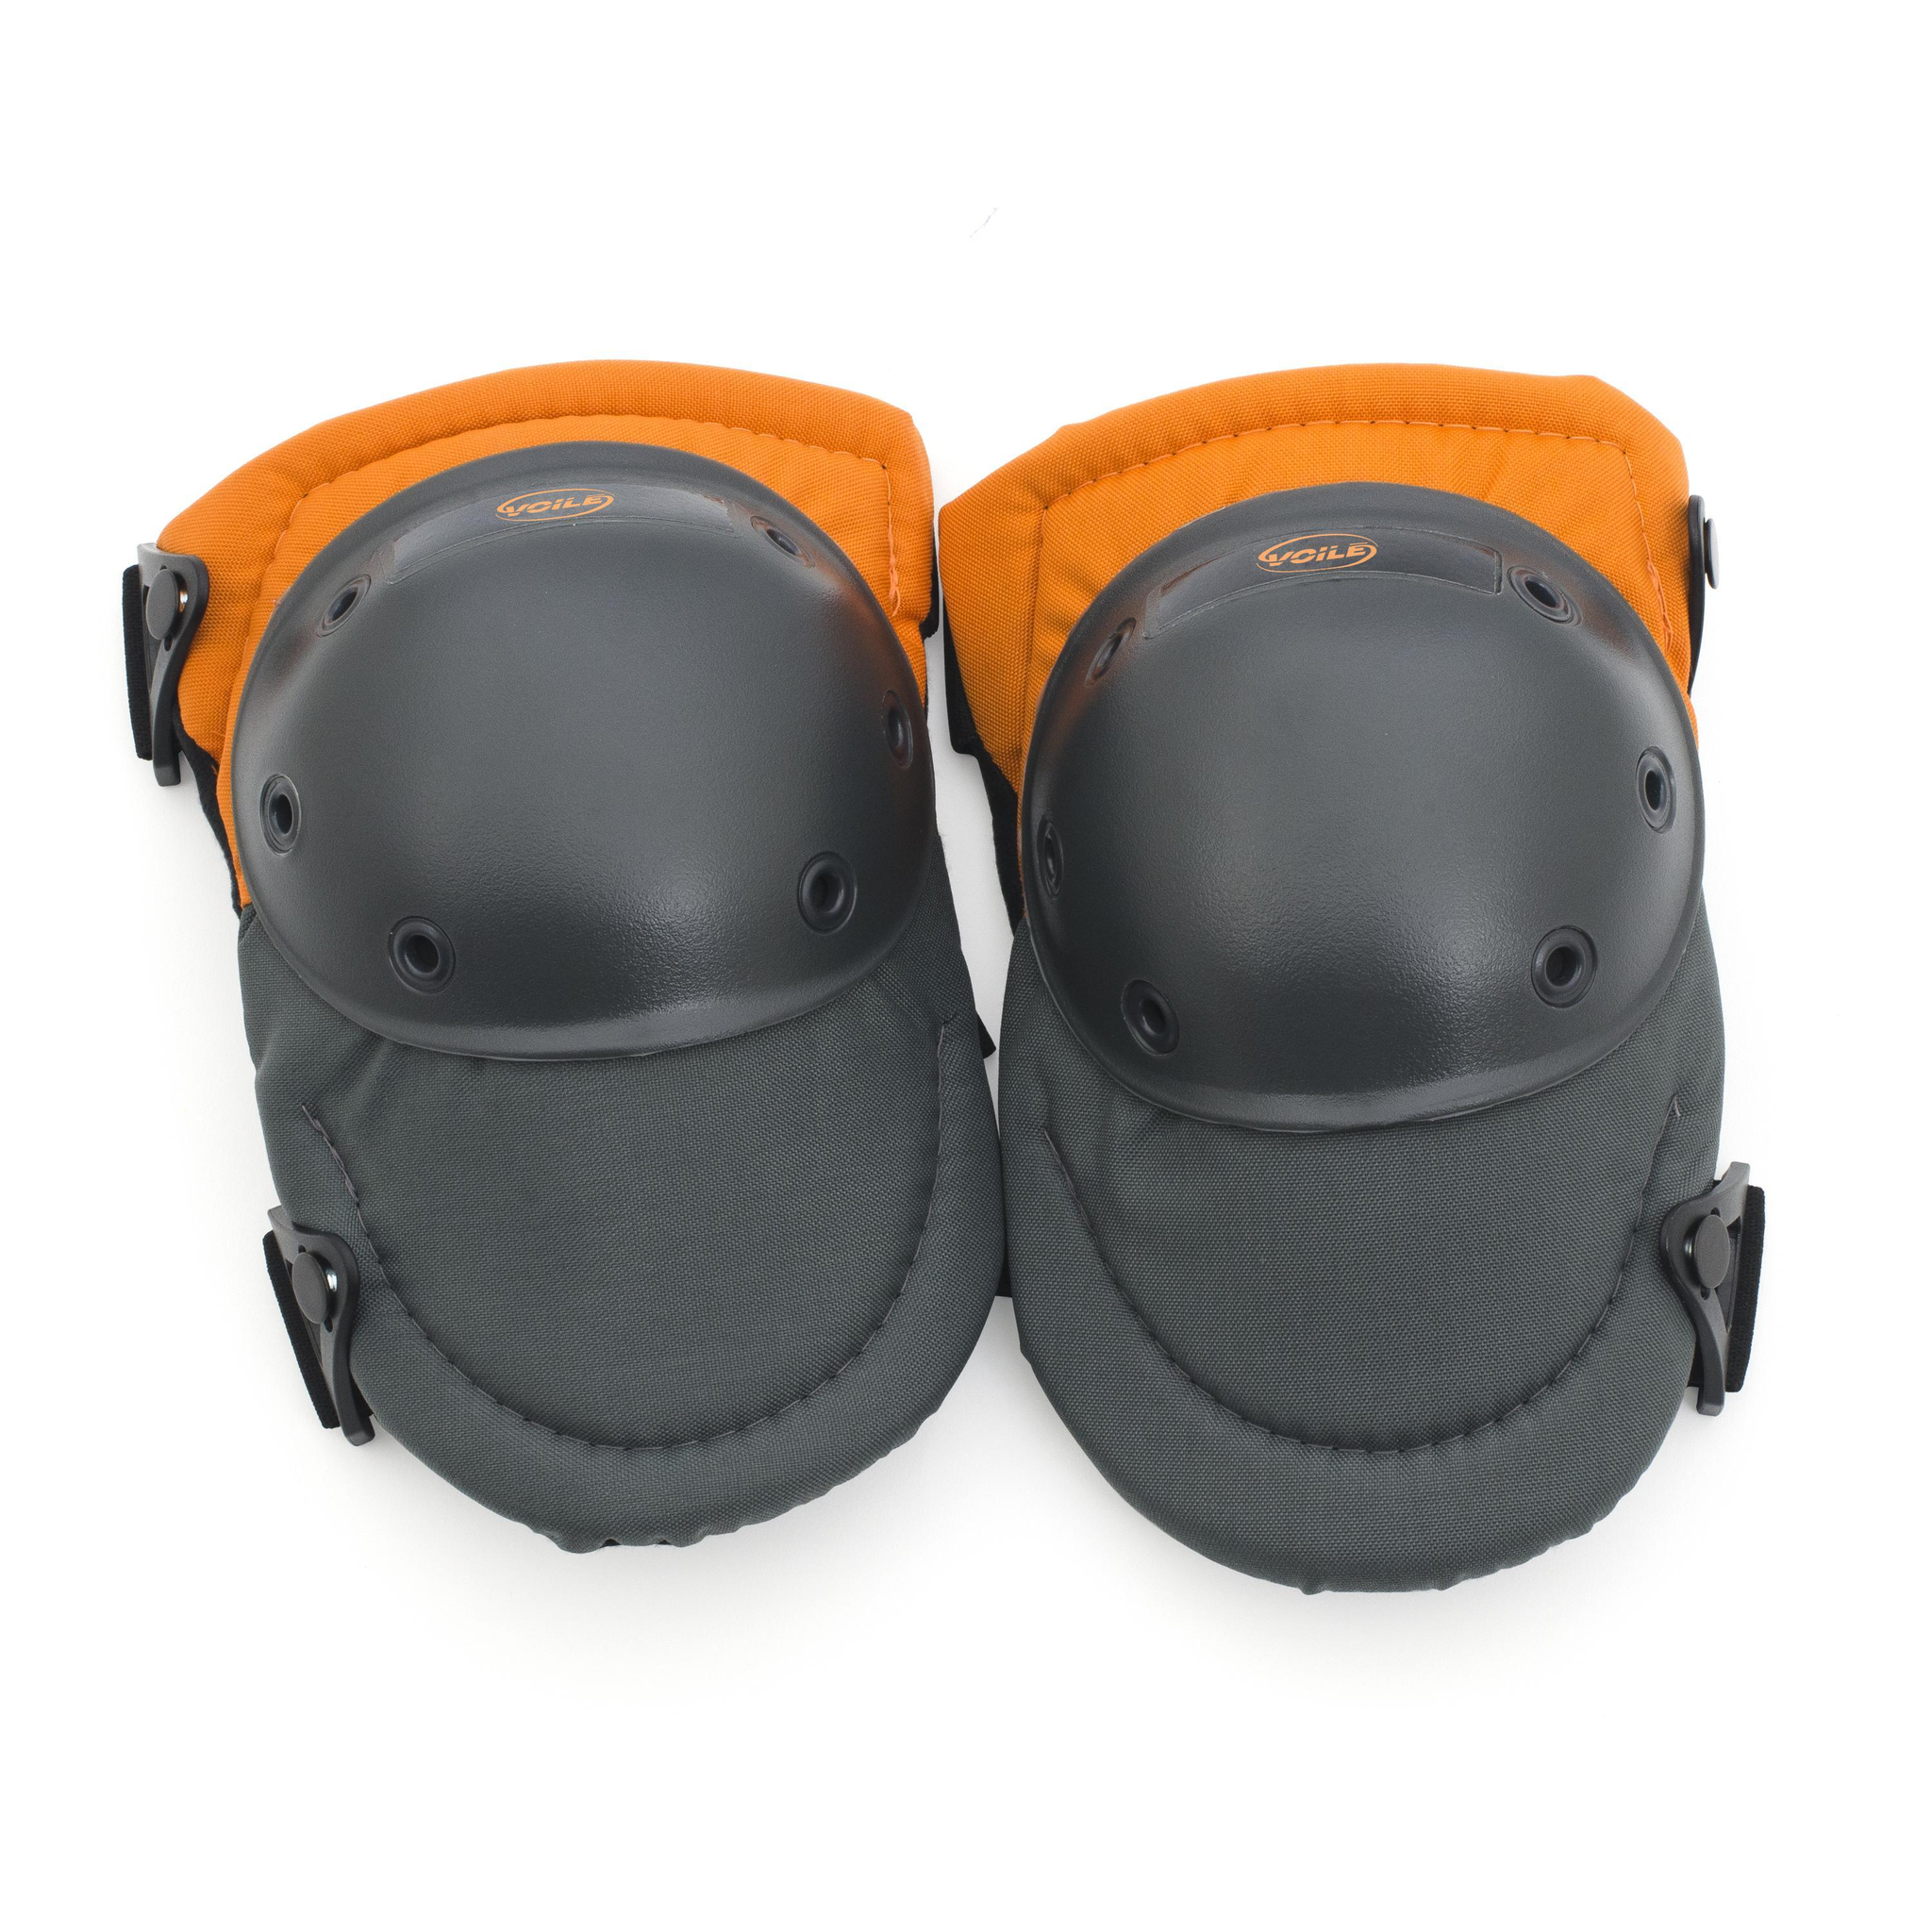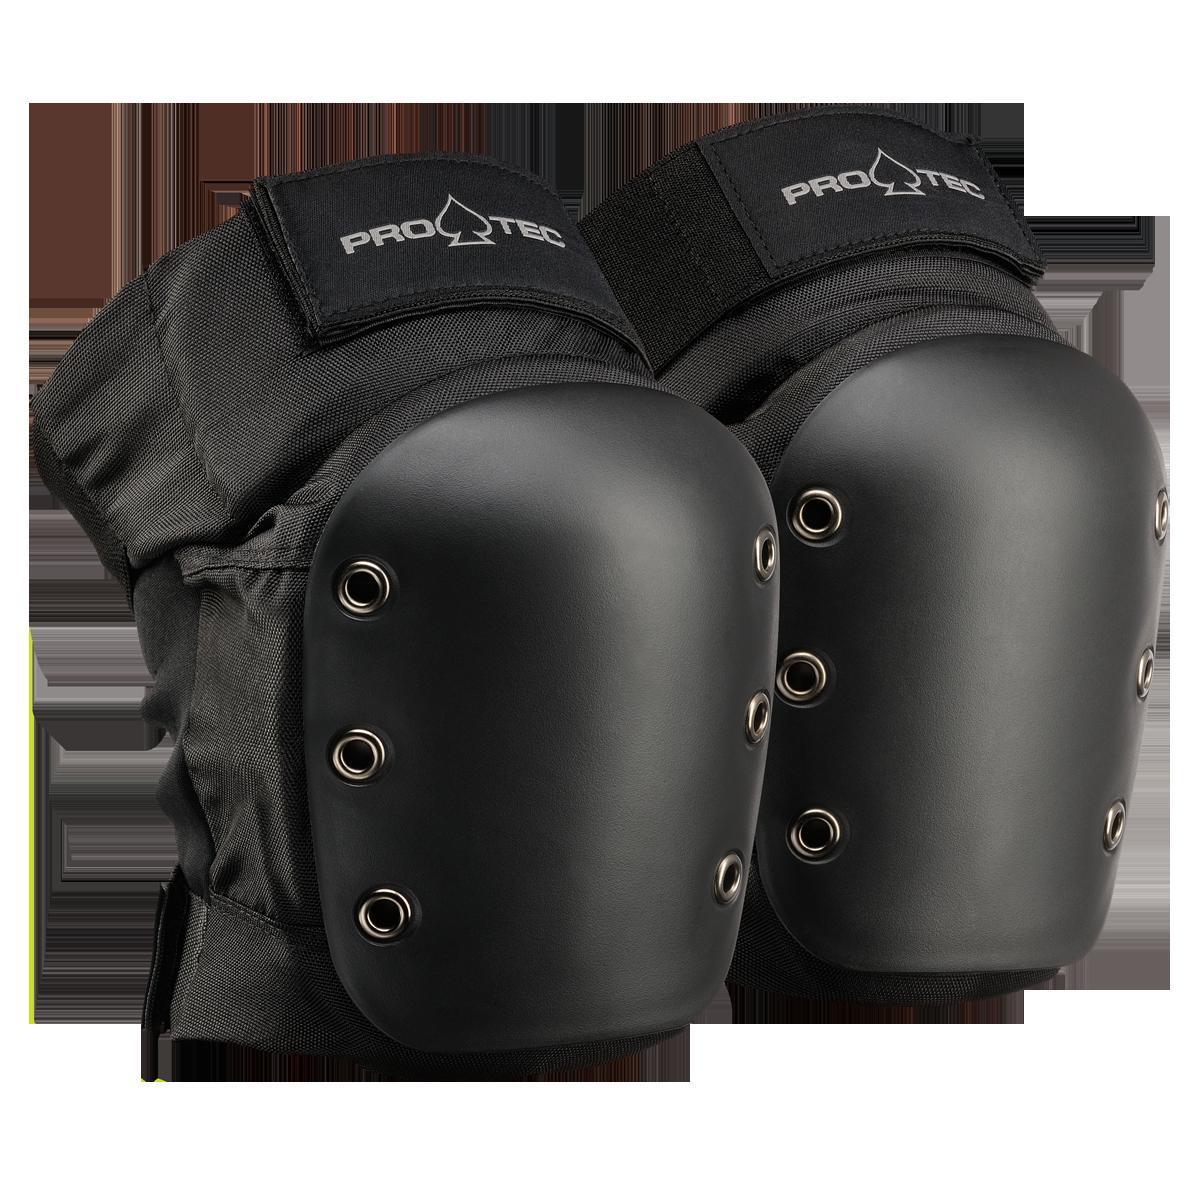The first image is the image on the left, the second image is the image on the right. Evaluate the accuracy of this statement regarding the images: "Left image features one pair of all-black knee pads with three eyelet rivets per side.". Is it true? Answer yes or no. No. The first image is the image on the left, the second image is the image on the right. Assess this claim about the two images: "There are exactly two velcro closures in the image on the left.". Correct or not? Answer yes or no. No. 